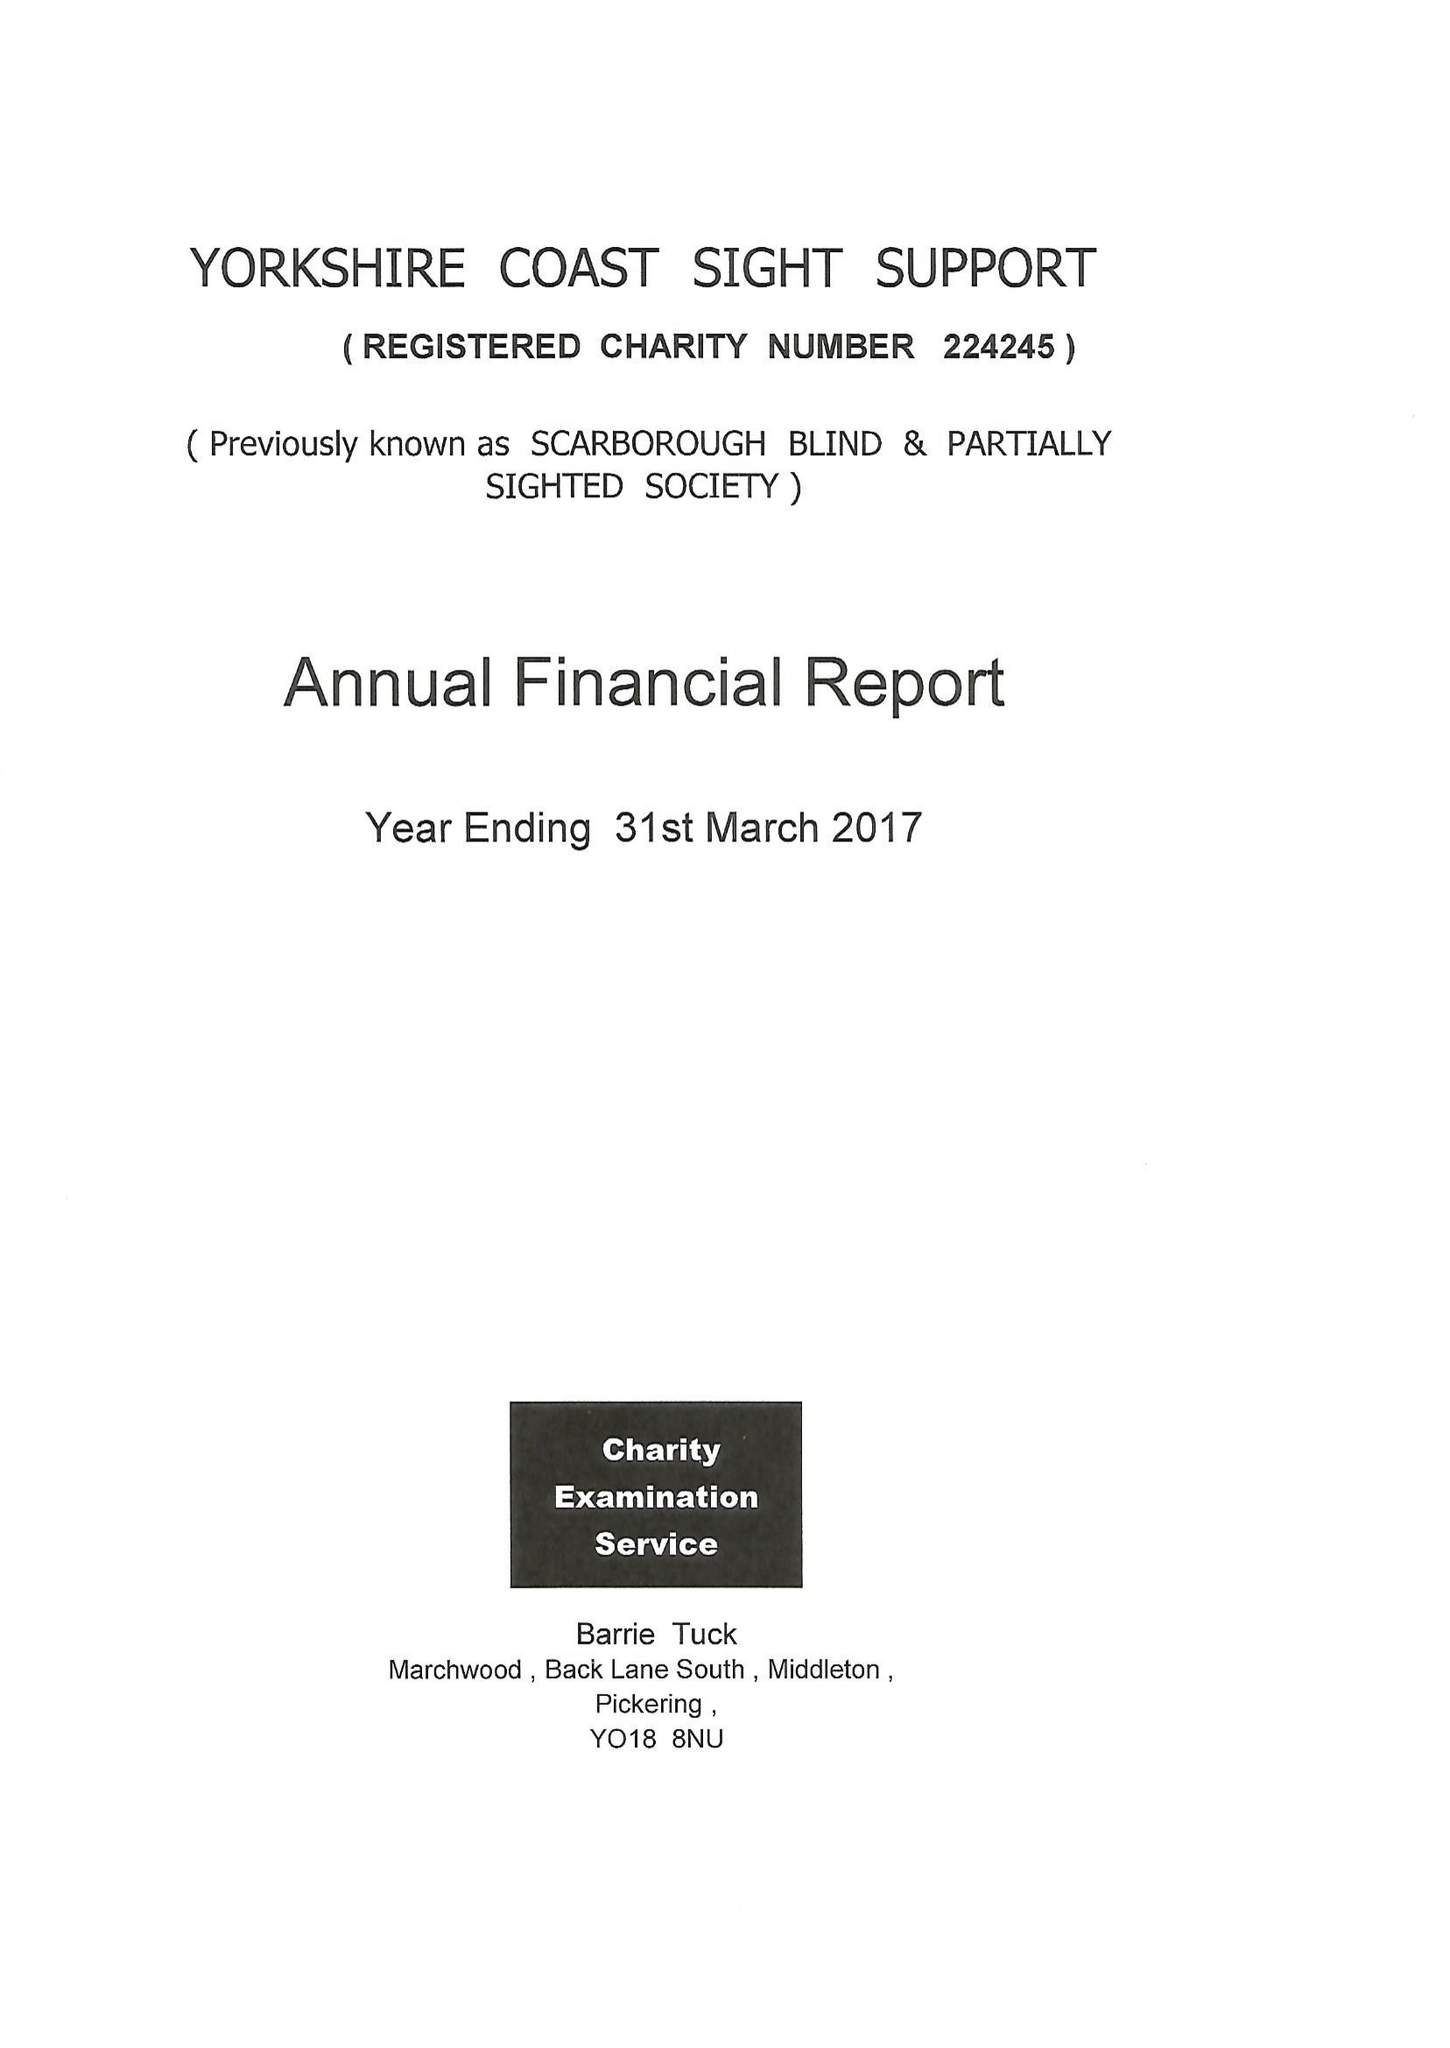What is the value for the spending_annually_in_british_pounds?
Answer the question using a single word or phrase. 103922.00 